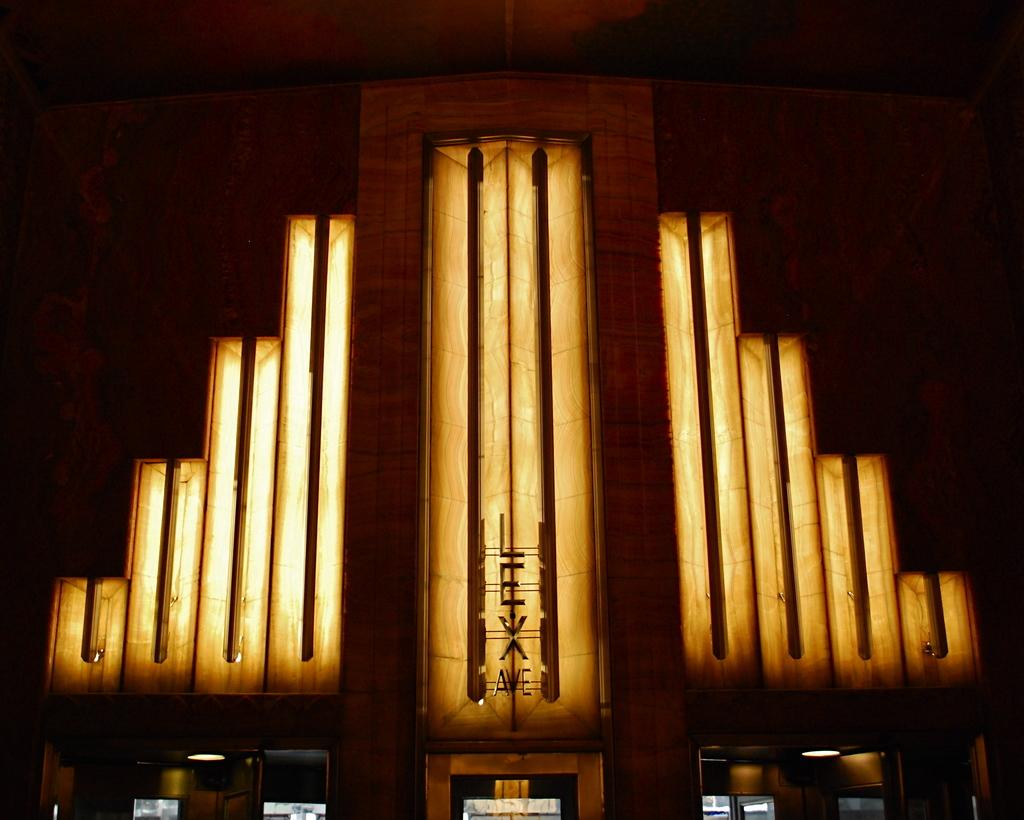What is present on the wall in the image? There are lights on the wall in the image. Can you describe the wall in the image? There is a wall in the image, and it has lights on it. What is written at the bottom of the picture? There is something written at the bottom of the picture, but we cannot determine the exact content from the provided facts. Where is your aunt sitting in the image? There is no mention of an aunt or any person sitting in the image. What type of shoe is visible in the image? There is no shoe present in the image. 